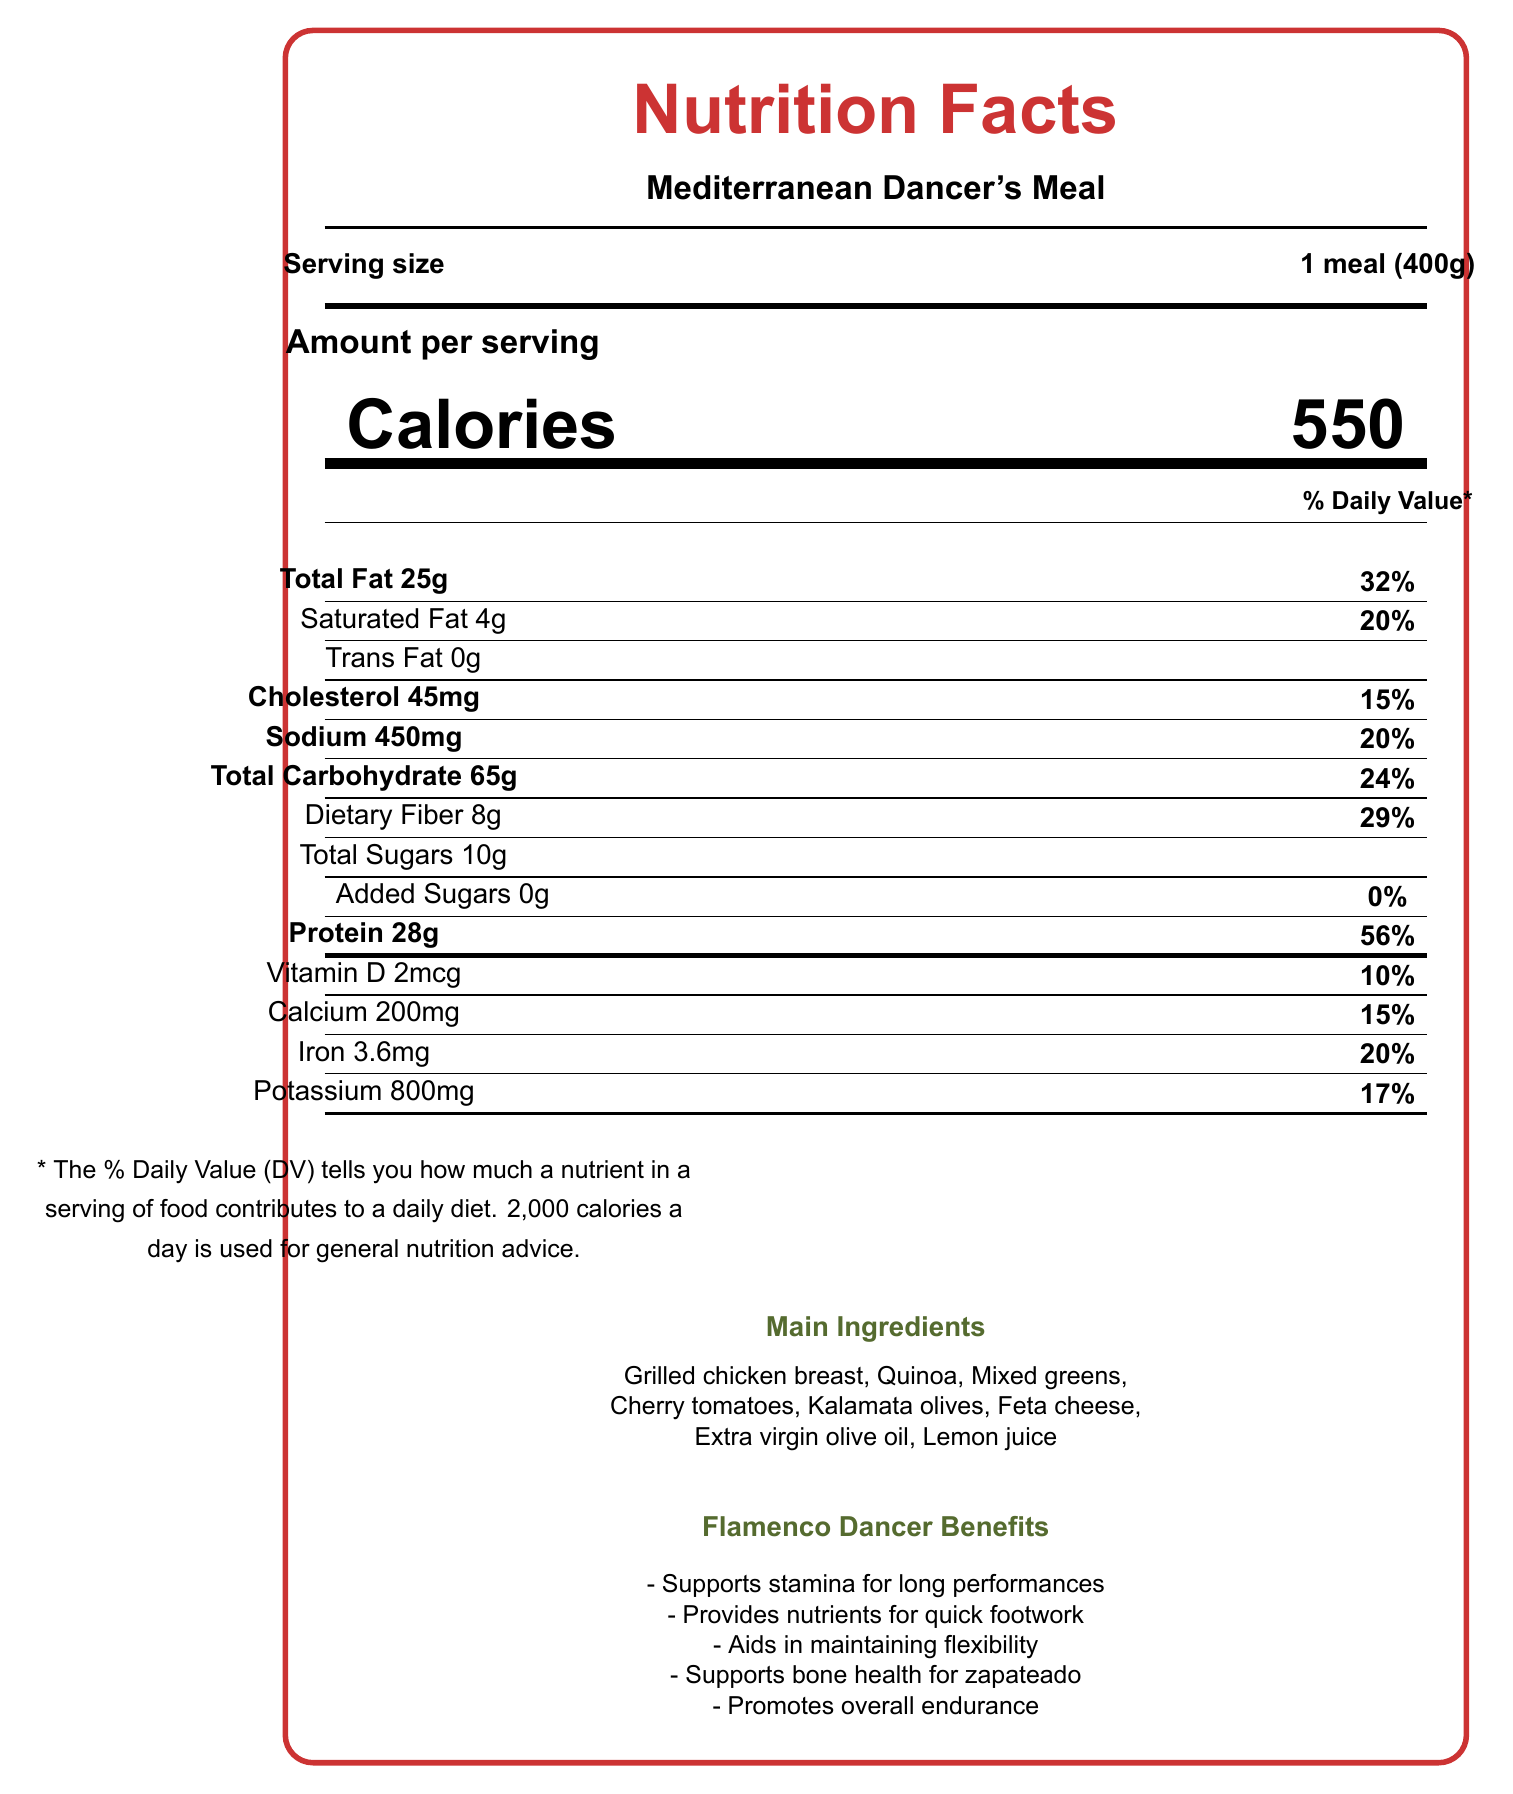what is the serving size for the meal? The serving size is clearly stated under the "Serving size" section as "1 meal (400g)".
Answer: 1 meal (400g) How many calories are in one serving of this meal? The total calories in one serving are displayed prominently as "Calories 550".
Answer: 550 How much protein does this meal provide per serving? The document specifies "Protein 28g" with a daily value percentage of 56%.
Answer: 28g Does this meal contain any trans fat? It shows "Trans Fat 0g," indicating there are no trans fats in the meal.
Answer: No What percentage of the daily value for dietary fiber does this meal provide? The meal provides "Dietary Fiber 8g" which is equivalent to 29% of the daily value.
Answer: 29% What are the main ingredients in this meal? The main ingredients are listed towards the bottom of the document under "Main Ingredients".
Answer: Grilled chicken breast, Quinoa, Mixed greens, Cherry tomatoes, Kalamata olives, Feta cheese, Extra virgin olive oil, Lemon juice Which component contributes most to muscle repair and growth? The document mentions that the high amount of lean protein "supports stamina for long rehearsals and performances."
Answer: Protein Which of these nutrients is not present in this meal? A. Calcium B. Vitamin C C. Vitamin D The document lists Vitamin D and Calcium but does not mention Vitamin C.
Answer: B What is the percentage daily value of calcium found in this meal? The meal contains 200mg of calcium, which is 15% of the daily value.
Answer: 15% Does this meal support a flamenco dancer's performance? The document highlights benefits specifically tailored for flamenco dancers, supporting various aspects of their performance.
Answer: Yes How does this meal help in maintaining flexibility for dancers? The dancer benefits section mentions that the meal aids in maintaining flexibility.
Answer: It provides essential nutrients. How much sodium does this meal contain? The meal contains "Sodium 450mg" which is 20% of the daily value.
Answer: 450mg Which benefit is not listed in the Flamenco Performance Notes? A. Supports bone health for zapateado B. Improves hand-eye coordination C. Promotes overall endurance D. Provides nutrients for quick footwork The listed flamenco performance notes do not mention improving hand-eye coordination.
Answer: B What is the main idea of this document? The document combines detailed nutrition facts with specific dancer benefits, particularly focusing on flamenco performance requirements.
Answer: The document provides detailed nutrition facts for a Mediterranean diet meal plan designed specifically for dancers, highlighting balanced nutrition and emphasizing benefits for flamenco performance. What is the source of added sugars in this meal? The document states that there are 0g of added sugars, but does not provide further details about the source of any sugars.
Answer: Cannot be determined 